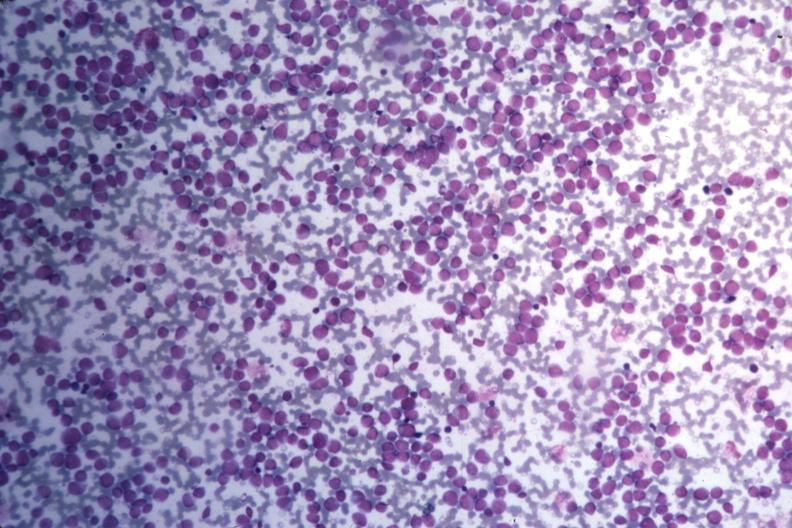s endocervical polyp present?
Answer the question using a single word or phrase. No 